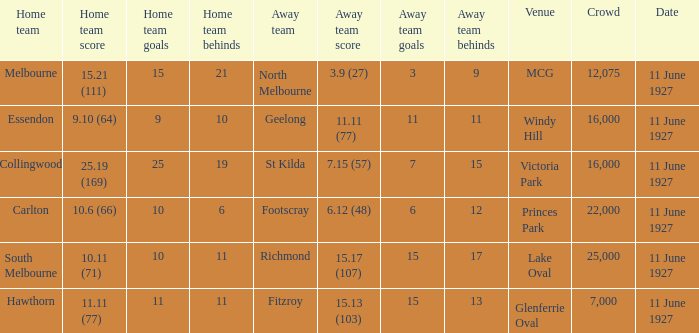Which home team competed against the away team Geelong? Essendon. 